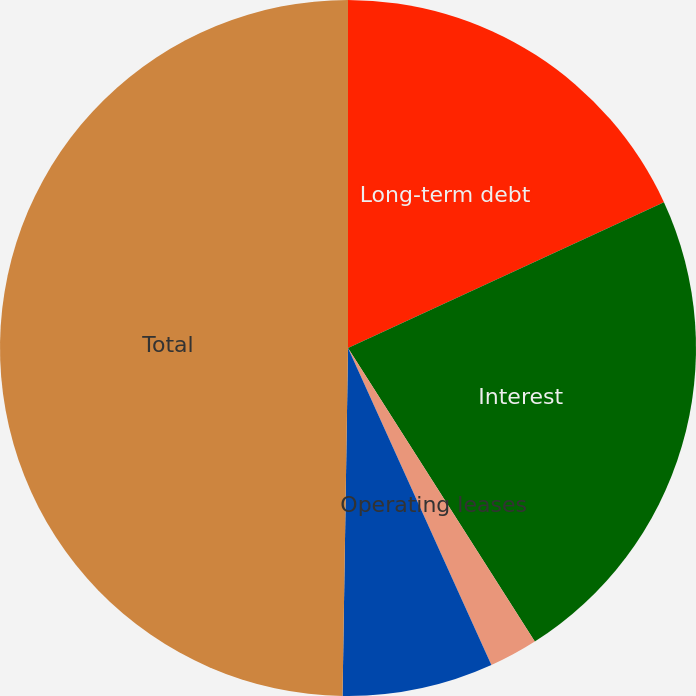Convert chart to OTSL. <chart><loc_0><loc_0><loc_500><loc_500><pie_chart><fcel>Long-term debt<fcel>Interest<fcel>Operating leases<fcel>Data processing and<fcel>Total<nl><fcel>18.12%<fcel>22.87%<fcel>2.26%<fcel>7.01%<fcel>49.76%<nl></chart> 